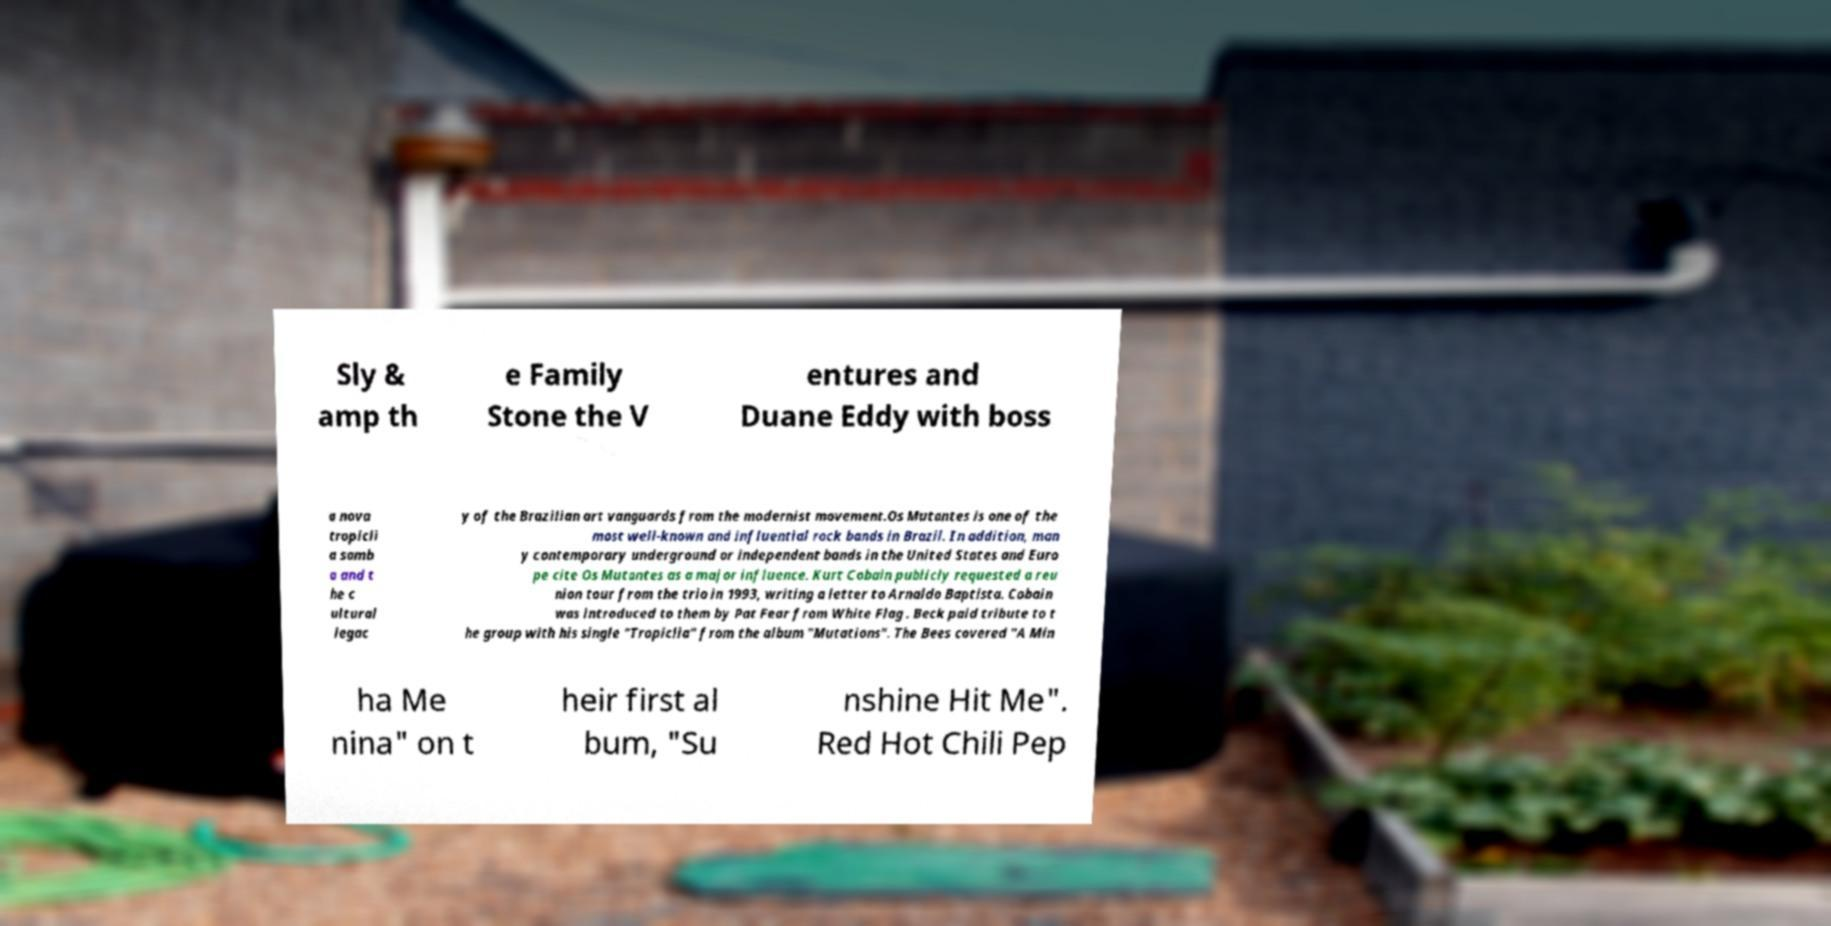What messages or text are displayed in this image? I need them in a readable, typed format. Sly & amp th e Family Stone the V entures and Duane Eddy with boss a nova tropicli a samb a and t he c ultural legac y of the Brazilian art vanguards from the modernist movement.Os Mutantes is one of the most well-known and influential rock bands in Brazil. In addition, man y contemporary underground or independent bands in the United States and Euro pe cite Os Mutantes as a major influence. Kurt Cobain publicly requested a reu nion tour from the trio in 1993, writing a letter to Arnaldo Baptista. Cobain was introduced to them by Pat Fear from White Flag . Beck paid tribute to t he group with his single "Tropiclia" from the album "Mutations". The Bees covered "A Min ha Me nina" on t heir first al bum, "Su nshine Hit Me". Red Hot Chili Pep 